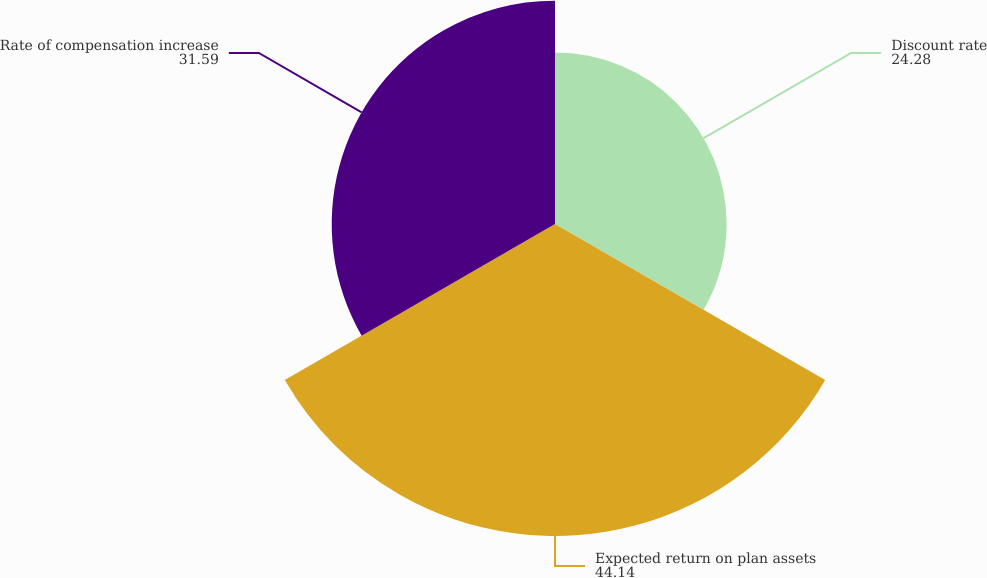Convert chart to OTSL. <chart><loc_0><loc_0><loc_500><loc_500><pie_chart><fcel>Discount rate<fcel>Expected return on plan assets<fcel>Rate of compensation increase<nl><fcel>24.28%<fcel>44.14%<fcel>31.59%<nl></chart> 